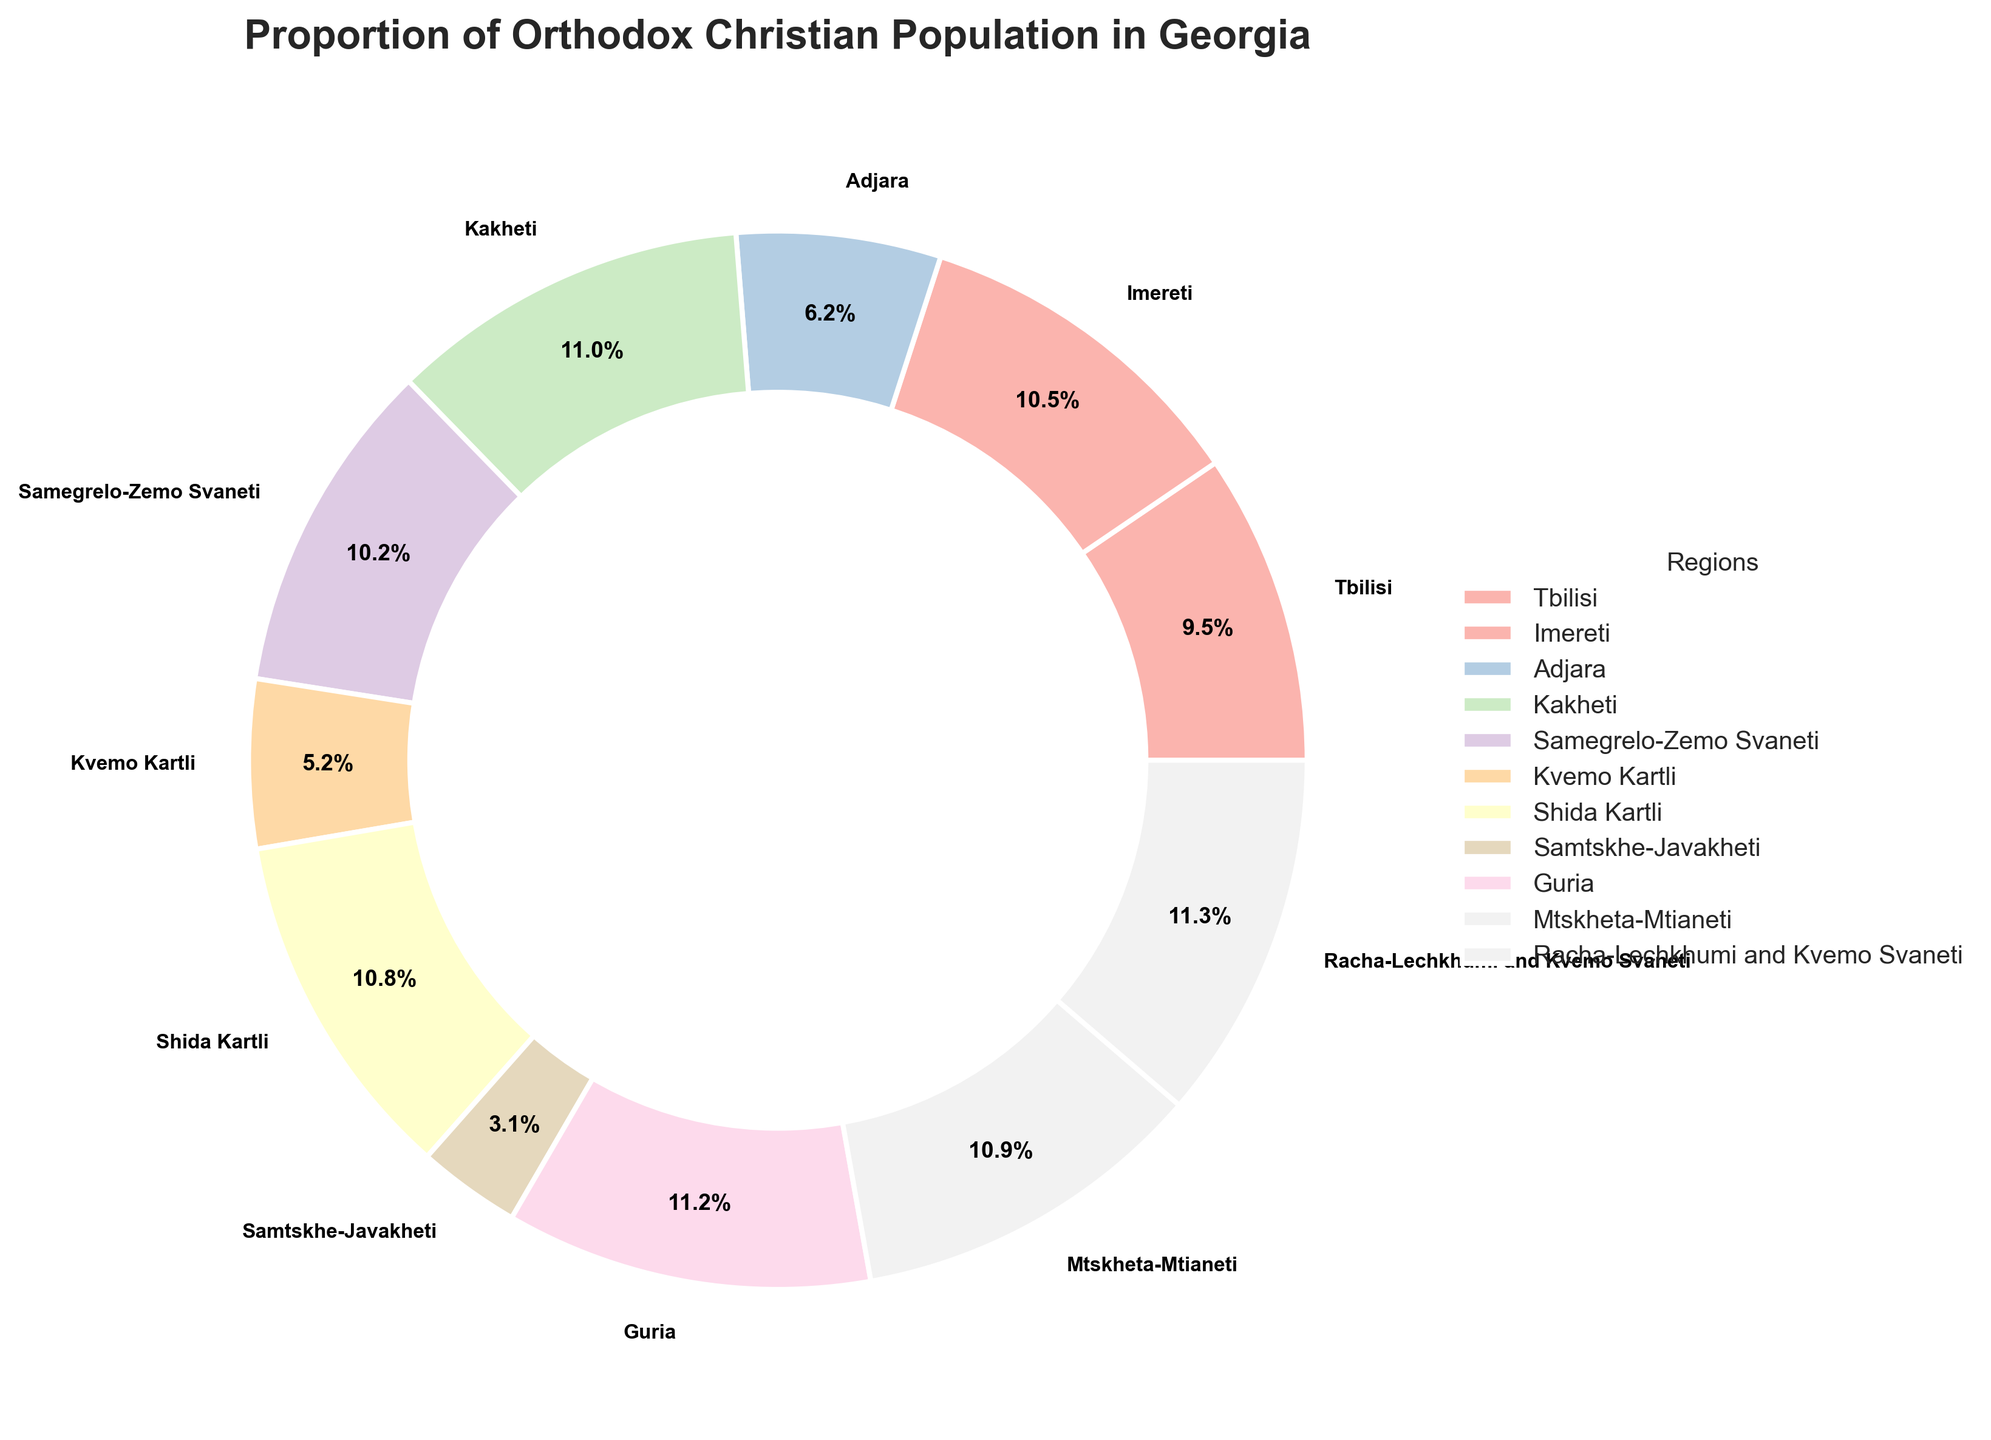What region has the highest proportion of Orthodox Christian population? From the pie chart, look at the segment with the highest percentage. This is marked as Racha-Lechkhumi and Kvemo Svaneti with 98.1%.
Answer: Racha-Lechkhumi and Kvemo Svaneti What is the difference in Orthodox Christian population proportion between the regions with the highest and lowest values? Identify Racha-Lechkhumi and Kvemo Svaneti with the highest proportion (98.1%) and Samtskhe-Javakheti with the lowest (27.3%). The difference is calculated as 98.1% - 27.3%.
Answer: 70.8% Which regions have a proportion of Orthodox Christian population greater than 90%? From the pie chart, examine all regions with percentages above 90%. These regions are Kakheti (95.7%), Shida Kartli (93.6%), Guria (97.2%), Mtskheta-Mtianeti (94.5%), and Racha-Lechkhumi and Kvemo Svaneti (98.1%).
Answer: Kakheti, Shida Kartli, Guria, Mtskheta-Mtianeti, Racha-Lechkhumi and Kvemo Svaneti How many regions have a population proportion lower than 50%? Check all segments with percentages below 50%. This includes Adjara (54.2%) and Kvemo Kartli (44.8%) only, but the exact number is needed, so count these regions.
Answer: 2 What is the combined proportion of Orthodox Christians in Tbilisi and Imereti? Find the percentage of Tbilisi (82.5%) and Imereti (91.3%), then sum them: 82.5% + 91.3%.
Answer: 173.8% What is the average proportion of Orthodox Christians in all regions? Sum all the percentages from the pie chart: 82.5% + 91.3% + 54.2% + 95.7% + 88.9% + 44.8% + 93.6% + 27.3% + 97.2% + 94.5% + 98.1%. Divide by the number of regions: (868.1 / 11).
Answer: 78.9% Which region has the proportion closest to the overall average? Calculate the overall average proportion (78.9%). Check each region’s percentage and find the one closest to this value, which is Samegrelo-Zemo Svaneti (88.9%) since it is closest to 78.9%.
Answer: Samegrelo-Zemo Svaneti Which region is represented with a wedge colored in the lightest shade in the pie chart? The lightest shade corresponds to the region with the lowest percentage, which is Samtskhe-Javakheti (27.3%).
Answer: Samtskhe-Javakheti What is the combined percentage of Orthodox Christians from the three regions with the smallest populations? Identify three regions with the smallest percentages: Samtskhe-Javakheti (27.3%), Kvemo Kartli (44.8%), and Adjara (54.2%). Sum these values: 27.3% + 44.8% + 54.2%.
Answer: 126.3% What is the percentage difference between Tbilisi and Shida Kartli? Find the percentages for Tbilisi (82.5%) and Shida Kartli (93.6%) and then calculate the difference: 93.6% - 82.5%.
Answer: 11.1% 